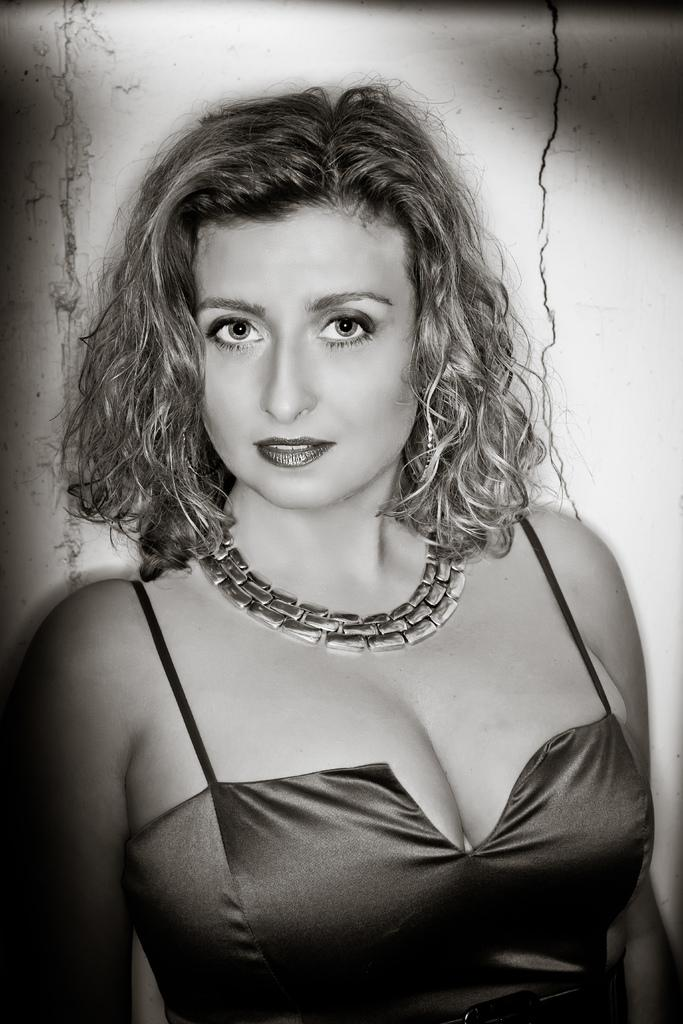Who is present in the image? There is a lady in the image. What can be seen on the wall behind the lady? There are cracks in the wall behind the lady. What type of bait is the lady using in the image? There is no bait present in the image; it features a lady and cracks in the wall. What kind of doll can be seen sitting on the lady's lap in the image? There is no doll present in the image; it only features a lady and cracks in the wall. 